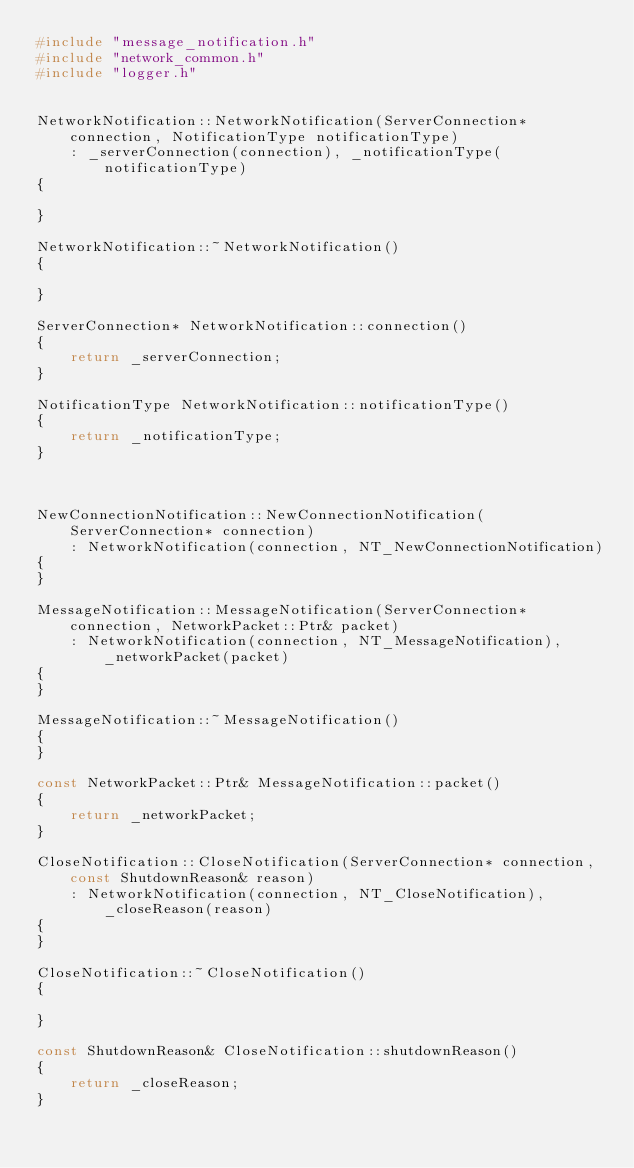Convert code to text. <code><loc_0><loc_0><loc_500><loc_500><_C++_>#include "message_notification.h"
#include "network_common.h"
#include "logger.h"


NetworkNotification::NetworkNotification(ServerConnection* connection, NotificationType notificationType)
    : _serverConnection(connection), _notificationType(notificationType)
{

}

NetworkNotification::~NetworkNotification()
{

}

ServerConnection* NetworkNotification::connection()
{
    return _serverConnection;
}

NotificationType NetworkNotification::notificationType()
{
    return _notificationType;
}



NewConnectionNotification::NewConnectionNotification(ServerConnection* connection)
    : NetworkNotification(connection, NT_NewConnectionNotification)
{
}

MessageNotification::MessageNotification(ServerConnection* connection, NetworkPacket::Ptr& packet)
    : NetworkNotification(connection, NT_MessageNotification), _networkPacket(packet)
{
}

MessageNotification::~MessageNotification()
{
}

const NetworkPacket::Ptr& MessageNotification::packet()
{
    return _networkPacket;
}

CloseNotification::CloseNotification(ServerConnection* connection, const ShutdownReason& reason)
    : NetworkNotification(connection, NT_CloseNotification), _closeReason(reason)
{
}

CloseNotification::~CloseNotification()
{

}

const ShutdownReason& CloseNotification::shutdownReason()
{
    return _closeReason;
}</code> 